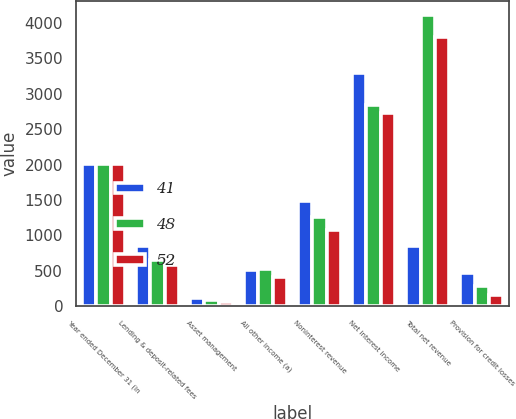<chart> <loc_0><loc_0><loc_500><loc_500><stacked_bar_chart><ecel><fcel>Year ended December 31 (in<fcel>Lending & deposit-related fees<fcel>Asset management<fcel>All other income (a)<fcel>Noninterest revenue<fcel>Net interest income<fcel>Total net revenue<fcel>Provision for credit losses<nl><fcel>41<fcel>2008<fcel>854<fcel>113<fcel>514<fcel>1481<fcel>3296<fcel>854<fcel>464<nl><fcel>48<fcel>2007<fcel>647<fcel>92<fcel>524<fcel>1263<fcel>2840<fcel>4103<fcel>279<nl><fcel>52<fcel>2006<fcel>589<fcel>67<fcel>417<fcel>1073<fcel>2727<fcel>3800<fcel>160<nl></chart> 